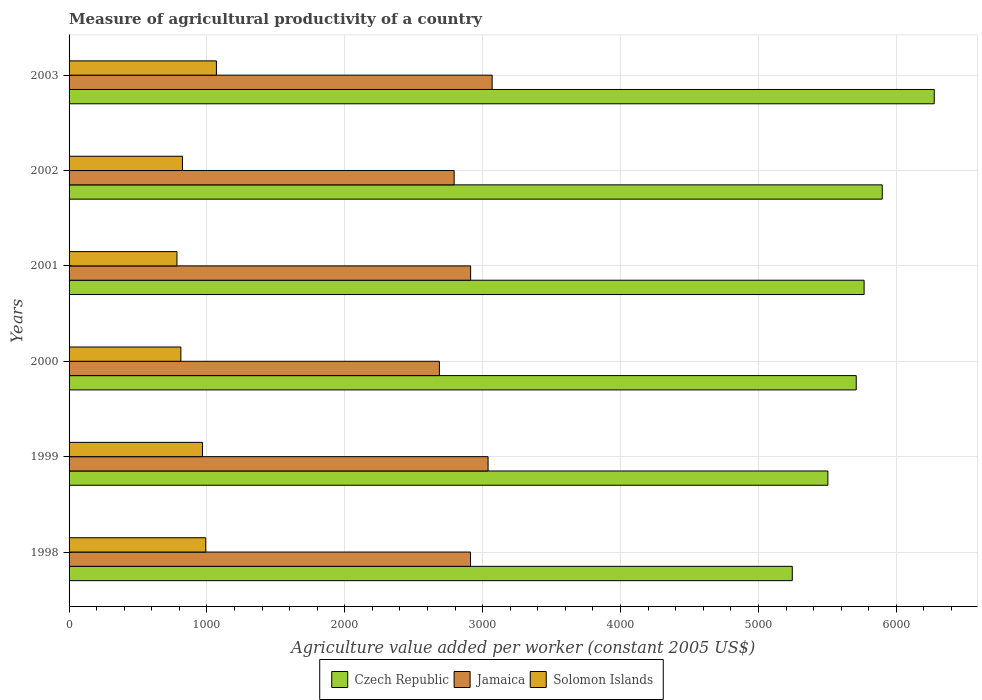How many groups of bars are there?
Give a very brief answer. 6. In how many cases, is the number of bars for a given year not equal to the number of legend labels?
Your answer should be compact. 0. What is the measure of agricultural productivity in Solomon Islands in 2002?
Give a very brief answer. 822.41. Across all years, what is the maximum measure of agricultural productivity in Jamaica?
Offer a terse response. 3068.65. Across all years, what is the minimum measure of agricultural productivity in Solomon Islands?
Provide a short and direct response. 782.48. In which year was the measure of agricultural productivity in Solomon Islands maximum?
Make the answer very short. 2003. In which year was the measure of agricultural productivity in Czech Republic minimum?
Provide a succinct answer. 1998. What is the total measure of agricultural productivity in Jamaica in the graph?
Ensure brevity in your answer.  1.74e+04. What is the difference between the measure of agricultural productivity in Jamaica in 2000 and that in 2003?
Your answer should be compact. -382.64. What is the difference between the measure of agricultural productivity in Czech Republic in 2000 and the measure of agricultural productivity in Solomon Islands in 2002?
Your answer should be very brief. 4886.95. What is the average measure of agricultural productivity in Solomon Islands per year?
Offer a very short reply. 907.22. In the year 1999, what is the difference between the measure of agricultural productivity in Solomon Islands and measure of agricultural productivity in Czech Republic?
Keep it short and to the point. -4535.83. In how many years, is the measure of agricultural productivity in Jamaica greater than 5200 US$?
Your answer should be very brief. 0. What is the ratio of the measure of agricultural productivity in Solomon Islands in 2000 to that in 2003?
Your response must be concise. 0.76. Is the difference between the measure of agricultural productivity in Solomon Islands in 2000 and 2002 greater than the difference between the measure of agricultural productivity in Czech Republic in 2000 and 2002?
Your response must be concise. Yes. What is the difference between the highest and the second highest measure of agricultural productivity in Czech Republic?
Offer a very short reply. 377.08. What is the difference between the highest and the lowest measure of agricultural productivity in Solomon Islands?
Give a very brief answer. 286.23. In how many years, is the measure of agricultural productivity in Jamaica greater than the average measure of agricultural productivity in Jamaica taken over all years?
Give a very brief answer. 4. Is the sum of the measure of agricultural productivity in Czech Republic in 2001 and 2003 greater than the maximum measure of agricultural productivity in Jamaica across all years?
Your answer should be very brief. Yes. What does the 1st bar from the top in 2001 represents?
Ensure brevity in your answer.  Solomon Islands. What does the 2nd bar from the bottom in 2000 represents?
Provide a succinct answer. Jamaica. How many bars are there?
Provide a short and direct response. 18. Are all the bars in the graph horizontal?
Keep it short and to the point. Yes. How many years are there in the graph?
Offer a very short reply. 6. Are the values on the major ticks of X-axis written in scientific E-notation?
Offer a very short reply. No. Does the graph contain any zero values?
Offer a terse response. No. Does the graph contain grids?
Offer a very short reply. Yes. Where does the legend appear in the graph?
Keep it short and to the point. Bottom center. How are the legend labels stacked?
Offer a terse response. Horizontal. What is the title of the graph?
Provide a succinct answer. Measure of agricultural productivity of a country. Does "Ireland" appear as one of the legend labels in the graph?
Make the answer very short. No. What is the label or title of the X-axis?
Ensure brevity in your answer.  Agriculture value added per worker (constant 2005 US$). What is the label or title of the Y-axis?
Give a very brief answer. Years. What is the Agriculture value added per worker (constant 2005 US$) in Czech Republic in 1998?
Your response must be concise. 5245.45. What is the Agriculture value added per worker (constant 2005 US$) in Jamaica in 1998?
Offer a terse response. 2911.57. What is the Agriculture value added per worker (constant 2005 US$) of Solomon Islands in 1998?
Give a very brief answer. 991.28. What is the Agriculture value added per worker (constant 2005 US$) of Czech Republic in 1999?
Provide a short and direct response. 5503.49. What is the Agriculture value added per worker (constant 2005 US$) of Jamaica in 1999?
Offer a very short reply. 3039.08. What is the Agriculture value added per worker (constant 2005 US$) of Solomon Islands in 1999?
Your response must be concise. 967.66. What is the Agriculture value added per worker (constant 2005 US$) in Czech Republic in 2000?
Your response must be concise. 5709.36. What is the Agriculture value added per worker (constant 2005 US$) of Jamaica in 2000?
Your answer should be compact. 2686.01. What is the Agriculture value added per worker (constant 2005 US$) of Solomon Islands in 2000?
Keep it short and to the point. 810.78. What is the Agriculture value added per worker (constant 2005 US$) of Czech Republic in 2001?
Offer a very short reply. 5766.48. What is the Agriculture value added per worker (constant 2005 US$) of Jamaica in 2001?
Your response must be concise. 2912.46. What is the Agriculture value added per worker (constant 2005 US$) in Solomon Islands in 2001?
Provide a short and direct response. 782.48. What is the Agriculture value added per worker (constant 2005 US$) in Czech Republic in 2002?
Provide a short and direct response. 5898.01. What is the Agriculture value added per worker (constant 2005 US$) in Jamaica in 2002?
Keep it short and to the point. 2793.05. What is the Agriculture value added per worker (constant 2005 US$) of Solomon Islands in 2002?
Keep it short and to the point. 822.41. What is the Agriculture value added per worker (constant 2005 US$) of Czech Republic in 2003?
Offer a very short reply. 6275.09. What is the Agriculture value added per worker (constant 2005 US$) of Jamaica in 2003?
Your answer should be very brief. 3068.65. What is the Agriculture value added per worker (constant 2005 US$) in Solomon Islands in 2003?
Your answer should be very brief. 1068.71. Across all years, what is the maximum Agriculture value added per worker (constant 2005 US$) in Czech Republic?
Provide a succinct answer. 6275.09. Across all years, what is the maximum Agriculture value added per worker (constant 2005 US$) in Jamaica?
Offer a terse response. 3068.65. Across all years, what is the maximum Agriculture value added per worker (constant 2005 US$) of Solomon Islands?
Your answer should be very brief. 1068.71. Across all years, what is the minimum Agriculture value added per worker (constant 2005 US$) in Czech Republic?
Keep it short and to the point. 5245.45. Across all years, what is the minimum Agriculture value added per worker (constant 2005 US$) of Jamaica?
Ensure brevity in your answer.  2686.01. Across all years, what is the minimum Agriculture value added per worker (constant 2005 US$) in Solomon Islands?
Keep it short and to the point. 782.48. What is the total Agriculture value added per worker (constant 2005 US$) of Czech Republic in the graph?
Provide a short and direct response. 3.44e+04. What is the total Agriculture value added per worker (constant 2005 US$) of Jamaica in the graph?
Keep it short and to the point. 1.74e+04. What is the total Agriculture value added per worker (constant 2005 US$) in Solomon Islands in the graph?
Your answer should be compact. 5443.32. What is the difference between the Agriculture value added per worker (constant 2005 US$) in Czech Republic in 1998 and that in 1999?
Make the answer very short. -258.04. What is the difference between the Agriculture value added per worker (constant 2005 US$) of Jamaica in 1998 and that in 1999?
Your response must be concise. -127.51. What is the difference between the Agriculture value added per worker (constant 2005 US$) in Solomon Islands in 1998 and that in 1999?
Give a very brief answer. 23.63. What is the difference between the Agriculture value added per worker (constant 2005 US$) of Czech Republic in 1998 and that in 2000?
Your answer should be very brief. -463.91. What is the difference between the Agriculture value added per worker (constant 2005 US$) of Jamaica in 1998 and that in 2000?
Give a very brief answer. 225.56. What is the difference between the Agriculture value added per worker (constant 2005 US$) in Solomon Islands in 1998 and that in 2000?
Provide a succinct answer. 180.5. What is the difference between the Agriculture value added per worker (constant 2005 US$) of Czech Republic in 1998 and that in 2001?
Offer a terse response. -521.03. What is the difference between the Agriculture value added per worker (constant 2005 US$) of Jamaica in 1998 and that in 2001?
Keep it short and to the point. -0.9. What is the difference between the Agriculture value added per worker (constant 2005 US$) in Solomon Islands in 1998 and that in 2001?
Give a very brief answer. 208.8. What is the difference between the Agriculture value added per worker (constant 2005 US$) in Czech Republic in 1998 and that in 2002?
Your answer should be compact. -652.56. What is the difference between the Agriculture value added per worker (constant 2005 US$) of Jamaica in 1998 and that in 2002?
Offer a terse response. 118.52. What is the difference between the Agriculture value added per worker (constant 2005 US$) in Solomon Islands in 1998 and that in 2002?
Keep it short and to the point. 168.87. What is the difference between the Agriculture value added per worker (constant 2005 US$) of Czech Republic in 1998 and that in 2003?
Ensure brevity in your answer.  -1029.64. What is the difference between the Agriculture value added per worker (constant 2005 US$) of Jamaica in 1998 and that in 2003?
Ensure brevity in your answer.  -157.08. What is the difference between the Agriculture value added per worker (constant 2005 US$) in Solomon Islands in 1998 and that in 2003?
Offer a terse response. -77.43. What is the difference between the Agriculture value added per worker (constant 2005 US$) of Czech Republic in 1999 and that in 2000?
Provide a short and direct response. -205.87. What is the difference between the Agriculture value added per worker (constant 2005 US$) in Jamaica in 1999 and that in 2000?
Provide a succinct answer. 353.07. What is the difference between the Agriculture value added per worker (constant 2005 US$) in Solomon Islands in 1999 and that in 2000?
Ensure brevity in your answer.  156.88. What is the difference between the Agriculture value added per worker (constant 2005 US$) in Czech Republic in 1999 and that in 2001?
Your answer should be compact. -262.99. What is the difference between the Agriculture value added per worker (constant 2005 US$) of Jamaica in 1999 and that in 2001?
Provide a short and direct response. 126.61. What is the difference between the Agriculture value added per worker (constant 2005 US$) of Solomon Islands in 1999 and that in 2001?
Keep it short and to the point. 185.18. What is the difference between the Agriculture value added per worker (constant 2005 US$) of Czech Republic in 1999 and that in 2002?
Give a very brief answer. -394.52. What is the difference between the Agriculture value added per worker (constant 2005 US$) of Jamaica in 1999 and that in 2002?
Your answer should be very brief. 246.03. What is the difference between the Agriculture value added per worker (constant 2005 US$) in Solomon Islands in 1999 and that in 2002?
Make the answer very short. 145.25. What is the difference between the Agriculture value added per worker (constant 2005 US$) of Czech Republic in 1999 and that in 2003?
Provide a short and direct response. -771.6. What is the difference between the Agriculture value added per worker (constant 2005 US$) in Jamaica in 1999 and that in 2003?
Provide a succinct answer. -29.57. What is the difference between the Agriculture value added per worker (constant 2005 US$) of Solomon Islands in 1999 and that in 2003?
Provide a short and direct response. -101.06. What is the difference between the Agriculture value added per worker (constant 2005 US$) of Czech Republic in 2000 and that in 2001?
Provide a succinct answer. -57.12. What is the difference between the Agriculture value added per worker (constant 2005 US$) in Jamaica in 2000 and that in 2001?
Make the answer very short. -226.46. What is the difference between the Agriculture value added per worker (constant 2005 US$) in Solomon Islands in 2000 and that in 2001?
Make the answer very short. 28.3. What is the difference between the Agriculture value added per worker (constant 2005 US$) in Czech Republic in 2000 and that in 2002?
Offer a terse response. -188.65. What is the difference between the Agriculture value added per worker (constant 2005 US$) of Jamaica in 2000 and that in 2002?
Your answer should be very brief. -107.04. What is the difference between the Agriculture value added per worker (constant 2005 US$) of Solomon Islands in 2000 and that in 2002?
Keep it short and to the point. -11.63. What is the difference between the Agriculture value added per worker (constant 2005 US$) in Czech Republic in 2000 and that in 2003?
Your answer should be very brief. -565.73. What is the difference between the Agriculture value added per worker (constant 2005 US$) in Jamaica in 2000 and that in 2003?
Offer a very short reply. -382.64. What is the difference between the Agriculture value added per worker (constant 2005 US$) of Solomon Islands in 2000 and that in 2003?
Your answer should be very brief. -257.93. What is the difference between the Agriculture value added per worker (constant 2005 US$) in Czech Republic in 2001 and that in 2002?
Keep it short and to the point. -131.53. What is the difference between the Agriculture value added per worker (constant 2005 US$) of Jamaica in 2001 and that in 2002?
Offer a terse response. 119.42. What is the difference between the Agriculture value added per worker (constant 2005 US$) in Solomon Islands in 2001 and that in 2002?
Keep it short and to the point. -39.93. What is the difference between the Agriculture value added per worker (constant 2005 US$) of Czech Republic in 2001 and that in 2003?
Your answer should be compact. -508.61. What is the difference between the Agriculture value added per worker (constant 2005 US$) of Jamaica in 2001 and that in 2003?
Ensure brevity in your answer.  -156.18. What is the difference between the Agriculture value added per worker (constant 2005 US$) in Solomon Islands in 2001 and that in 2003?
Keep it short and to the point. -286.23. What is the difference between the Agriculture value added per worker (constant 2005 US$) of Czech Republic in 2002 and that in 2003?
Provide a short and direct response. -377.08. What is the difference between the Agriculture value added per worker (constant 2005 US$) in Jamaica in 2002 and that in 2003?
Provide a short and direct response. -275.6. What is the difference between the Agriculture value added per worker (constant 2005 US$) in Solomon Islands in 2002 and that in 2003?
Give a very brief answer. -246.3. What is the difference between the Agriculture value added per worker (constant 2005 US$) in Czech Republic in 1998 and the Agriculture value added per worker (constant 2005 US$) in Jamaica in 1999?
Provide a succinct answer. 2206.37. What is the difference between the Agriculture value added per worker (constant 2005 US$) in Czech Republic in 1998 and the Agriculture value added per worker (constant 2005 US$) in Solomon Islands in 1999?
Provide a short and direct response. 4277.79. What is the difference between the Agriculture value added per worker (constant 2005 US$) in Jamaica in 1998 and the Agriculture value added per worker (constant 2005 US$) in Solomon Islands in 1999?
Give a very brief answer. 1943.91. What is the difference between the Agriculture value added per worker (constant 2005 US$) in Czech Republic in 1998 and the Agriculture value added per worker (constant 2005 US$) in Jamaica in 2000?
Offer a terse response. 2559.44. What is the difference between the Agriculture value added per worker (constant 2005 US$) of Czech Republic in 1998 and the Agriculture value added per worker (constant 2005 US$) of Solomon Islands in 2000?
Make the answer very short. 4434.67. What is the difference between the Agriculture value added per worker (constant 2005 US$) of Jamaica in 1998 and the Agriculture value added per worker (constant 2005 US$) of Solomon Islands in 2000?
Your answer should be compact. 2100.79. What is the difference between the Agriculture value added per worker (constant 2005 US$) of Czech Republic in 1998 and the Agriculture value added per worker (constant 2005 US$) of Jamaica in 2001?
Your answer should be compact. 2332.99. What is the difference between the Agriculture value added per worker (constant 2005 US$) in Czech Republic in 1998 and the Agriculture value added per worker (constant 2005 US$) in Solomon Islands in 2001?
Give a very brief answer. 4462.97. What is the difference between the Agriculture value added per worker (constant 2005 US$) in Jamaica in 1998 and the Agriculture value added per worker (constant 2005 US$) in Solomon Islands in 2001?
Your answer should be very brief. 2129.08. What is the difference between the Agriculture value added per worker (constant 2005 US$) in Czech Republic in 1998 and the Agriculture value added per worker (constant 2005 US$) in Jamaica in 2002?
Offer a terse response. 2452.4. What is the difference between the Agriculture value added per worker (constant 2005 US$) in Czech Republic in 1998 and the Agriculture value added per worker (constant 2005 US$) in Solomon Islands in 2002?
Keep it short and to the point. 4423.04. What is the difference between the Agriculture value added per worker (constant 2005 US$) of Jamaica in 1998 and the Agriculture value added per worker (constant 2005 US$) of Solomon Islands in 2002?
Make the answer very short. 2089.16. What is the difference between the Agriculture value added per worker (constant 2005 US$) of Czech Republic in 1998 and the Agriculture value added per worker (constant 2005 US$) of Jamaica in 2003?
Your answer should be compact. 2176.8. What is the difference between the Agriculture value added per worker (constant 2005 US$) in Czech Republic in 1998 and the Agriculture value added per worker (constant 2005 US$) in Solomon Islands in 2003?
Your answer should be compact. 4176.74. What is the difference between the Agriculture value added per worker (constant 2005 US$) in Jamaica in 1998 and the Agriculture value added per worker (constant 2005 US$) in Solomon Islands in 2003?
Give a very brief answer. 1842.85. What is the difference between the Agriculture value added per worker (constant 2005 US$) in Czech Republic in 1999 and the Agriculture value added per worker (constant 2005 US$) in Jamaica in 2000?
Your answer should be compact. 2817.48. What is the difference between the Agriculture value added per worker (constant 2005 US$) in Czech Republic in 1999 and the Agriculture value added per worker (constant 2005 US$) in Solomon Islands in 2000?
Your answer should be compact. 4692.71. What is the difference between the Agriculture value added per worker (constant 2005 US$) in Jamaica in 1999 and the Agriculture value added per worker (constant 2005 US$) in Solomon Islands in 2000?
Ensure brevity in your answer.  2228.3. What is the difference between the Agriculture value added per worker (constant 2005 US$) of Czech Republic in 1999 and the Agriculture value added per worker (constant 2005 US$) of Jamaica in 2001?
Provide a succinct answer. 2591.03. What is the difference between the Agriculture value added per worker (constant 2005 US$) of Czech Republic in 1999 and the Agriculture value added per worker (constant 2005 US$) of Solomon Islands in 2001?
Offer a very short reply. 4721.01. What is the difference between the Agriculture value added per worker (constant 2005 US$) of Jamaica in 1999 and the Agriculture value added per worker (constant 2005 US$) of Solomon Islands in 2001?
Offer a very short reply. 2256.6. What is the difference between the Agriculture value added per worker (constant 2005 US$) of Czech Republic in 1999 and the Agriculture value added per worker (constant 2005 US$) of Jamaica in 2002?
Provide a short and direct response. 2710.44. What is the difference between the Agriculture value added per worker (constant 2005 US$) of Czech Republic in 1999 and the Agriculture value added per worker (constant 2005 US$) of Solomon Islands in 2002?
Keep it short and to the point. 4681.08. What is the difference between the Agriculture value added per worker (constant 2005 US$) in Jamaica in 1999 and the Agriculture value added per worker (constant 2005 US$) in Solomon Islands in 2002?
Keep it short and to the point. 2216.67. What is the difference between the Agriculture value added per worker (constant 2005 US$) in Czech Republic in 1999 and the Agriculture value added per worker (constant 2005 US$) in Jamaica in 2003?
Your answer should be very brief. 2434.84. What is the difference between the Agriculture value added per worker (constant 2005 US$) in Czech Republic in 1999 and the Agriculture value added per worker (constant 2005 US$) in Solomon Islands in 2003?
Your answer should be compact. 4434.78. What is the difference between the Agriculture value added per worker (constant 2005 US$) of Jamaica in 1999 and the Agriculture value added per worker (constant 2005 US$) of Solomon Islands in 2003?
Your answer should be very brief. 1970.36. What is the difference between the Agriculture value added per worker (constant 2005 US$) in Czech Republic in 2000 and the Agriculture value added per worker (constant 2005 US$) in Jamaica in 2001?
Make the answer very short. 2796.9. What is the difference between the Agriculture value added per worker (constant 2005 US$) of Czech Republic in 2000 and the Agriculture value added per worker (constant 2005 US$) of Solomon Islands in 2001?
Your response must be concise. 4926.88. What is the difference between the Agriculture value added per worker (constant 2005 US$) of Jamaica in 2000 and the Agriculture value added per worker (constant 2005 US$) of Solomon Islands in 2001?
Your answer should be very brief. 1903.53. What is the difference between the Agriculture value added per worker (constant 2005 US$) in Czech Republic in 2000 and the Agriculture value added per worker (constant 2005 US$) in Jamaica in 2002?
Give a very brief answer. 2916.31. What is the difference between the Agriculture value added per worker (constant 2005 US$) of Czech Republic in 2000 and the Agriculture value added per worker (constant 2005 US$) of Solomon Islands in 2002?
Offer a very short reply. 4886.95. What is the difference between the Agriculture value added per worker (constant 2005 US$) of Jamaica in 2000 and the Agriculture value added per worker (constant 2005 US$) of Solomon Islands in 2002?
Your response must be concise. 1863.6. What is the difference between the Agriculture value added per worker (constant 2005 US$) of Czech Republic in 2000 and the Agriculture value added per worker (constant 2005 US$) of Jamaica in 2003?
Offer a terse response. 2640.71. What is the difference between the Agriculture value added per worker (constant 2005 US$) in Czech Republic in 2000 and the Agriculture value added per worker (constant 2005 US$) in Solomon Islands in 2003?
Your answer should be very brief. 4640.65. What is the difference between the Agriculture value added per worker (constant 2005 US$) in Jamaica in 2000 and the Agriculture value added per worker (constant 2005 US$) in Solomon Islands in 2003?
Offer a very short reply. 1617.29. What is the difference between the Agriculture value added per worker (constant 2005 US$) of Czech Republic in 2001 and the Agriculture value added per worker (constant 2005 US$) of Jamaica in 2002?
Offer a terse response. 2973.43. What is the difference between the Agriculture value added per worker (constant 2005 US$) in Czech Republic in 2001 and the Agriculture value added per worker (constant 2005 US$) in Solomon Islands in 2002?
Ensure brevity in your answer.  4944.07. What is the difference between the Agriculture value added per worker (constant 2005 US$) in Jamaica in 2001 and the Agriculture value added per worker (constant 2005 US$) in Solomon Islands in 2002?
Keep it short and to the point. 2090.05. What is the difference between the Agriculture value added per worker (constant 2005 US$) of Czech Republic in 2001 and the Agriculture value added per worker (constant 2005 US$) of Jamaica in 2003?
Give a very brief answer. 2697.83. What is the difference between the Agriculture value added per worker (constant 2005 US$) of Czech Republic in 2001 and the Agriculture value added per worker (constant 2005 US$) of Solomon Islands in 2003?
Keep it short and to the point. 4697.77. What is the difference between the Agriculture value added per worker (constant 2005 US$) of Jamaica in 2001 and the Agriculture value added per worker (constant 2005 US$) of Solomon Islands in 2003?
Provide a succinct answer. 1843.75. What is the difference between the Agriculture value added per worker (constant 2005 US$) of Czech Republic in 2002 and the Agriculture value added per worker (constant 2005 US$) of Jamaica in 2003?
Your answer should be very brief. 2829.36. What is the difference between the Agriculture value added per worker (constant 2005 US$) in Czech Republic in 2002 and the Agriculture value added per worker (constant 2005 US$) in Solomon Islands in 2003?
Provide a short and direct response. 4829.29. What is the difference between the Agriculture value added per worker (constant 2005 US$) in Jamaica in 2002 and the Agriculture value added per worker (constant 2005 US$) in Solomon Islands in 2003?
Keep it short and to the point. 1724.33. What is the average Agriculture value added per worker (constant 2005 US$) in Czech Republic per year?
Your response must be concise. 5732.98. What is the average Agriculture value added per worker (constant 2005 US$) in Jamaica per year?
Give a very brief answer. 2901.8. What is the average Agriculture value added per worker (constant 2005 US$) in Solomon Islands per year?
Offer a terse response. 907.22. In the year 1998, what is the difference between the Agriculture value added per worker (constant 2005 US$) in Czech Republic and Agriculture value added per worker (constant 2005 US$) in Jamaica?
Provide a short and direct response. 2333.88. In the year 1998, what is the difference between the Agriculture value added per worker (constant 2005 US$) of Czech Republic and Agriculture value added per worker (constant 2005 US$) of Solomon Islands?
Offer a terse response. 4254.17. In the year 1998, what is the difference between the Agriculture value added per worker (constant 2005 US$) of Jamaica and Agriculture value added per worker (constant 2005 US$) of Solomon Islands?
Offer a terse response. 1920.28. In the year 1999, what is the difference between the Agriculture value added per worker (constant 2005 US$) in Czech Republic and Agriculture value added per worker (constant 2005 US$) in Jamaica?
Make the answer very short. 2464.41. In the year 1999, what is the difference between the Agriculture value added per worker (constant 2005 US$) of Czech Republic and Agriculture value added per worker (constant 2005 US$) of Solomon Islands?
Provide a short and direct response. 4535.83. In the year 1999, what is the difference between the Agriculture value added per worker (constant 2005 US$) of Jamaica and Agriculture value added per worker (constant 2005 US$) of Solomon Islands?
Provide a succinct answer. 2071.42. In the year 2000, what is the difference between the Agriculture value added per worker (constant 2005 US$) of Czech Republic and Agriculture value added per worker (constant 2005 US$) of Jamaica?
Provide a short and direct response. 3023.35. In the year 2000, what is the difference between the Agriculture value added per worker (constant 2005 US$) in Czech Republic and Agriculture value added per worker (constant 2005 US$) in Solomon Islands?
Give a very brief answer. 4898.58. In the year 2000, what is the difference between the Agriculture value added per worker (constant 2005 US$) in Jamaica and Agriculture value added per worker (constant 2005 US$) in Solomon Islands?
Give a very brief answer. 1875.23. In the year 2001, what is the difference between the Agriculture value added per worker (constant 2005 US$) of Czech Republic and Agriculture value added per worker (constant 2005 US$) of Jamaica?
Give a very brief answer. 2854.02. In the year 2001, what is the difference between the Agriculture value added per worker (constant 2005 US$) of Czech Republic and Agriculture value added per worker (constant 2005 US$) of Solomon Islands?
Make the answer very short. 4984. In the year 2001, what is the difference between the Agriculture value added per worker (constant 2005 US$) of Jamaica and Agriculture value added per worker (constant 2005 US$) of Solomon Islands?
Make the answer very short. 2129.98. In the year 2002, what is the difference between the Agriculture value added per worker (constant 2005 US$) of Czech Republic and Agriculture value added per worker (constant 2005 US$) of Jamaica?
Keep it short and to the point. 3104.96. In the year 2002, what is the difference between the Agriculture value added per worker (constant 2005 US$) of Czech Republic and Agriculture value added per worker (constant 2005 US$) of Solomon Islands?
Offer a very short reply. 5075.6. In the year 2002, what is the difference between the Agriculture value added per worker (constant 2005 US$) of Jamaica and Agriculture value added per worker (constant 2005 US$) of Solomon Islands?
Offer a terse response. 1970.64. In the year 2003, what is the difference between the Agriculture value added per worker (constant 2005 US$) in Czech Republic and Agriculture value added per worker (constant 2005 US$) in Jamaica?
Your response must be concise. 3206.44. In the year 2003, what is the difference between the Agriculture value added per worker (constant 2005 US$) in Czech Republic and Agriculture value added per worker (constant 2005 US$) in Solomon Islands?
Provide a succinct answer. 5206.38. In the year 2003, what is the difference between the Agriculture value added per worker (constant 2005 US$) in Jamaica and Agriculture value added per worker (constant 2005 US$) in Solomon Islands?
Provide a succinct answer. 1999.93. What is the ratio of the Agriculture value added per worker (constant 2005 US$) in Czech Republic in 1998 to that in 1999?
Provide a succinct answer. 0.95. What is the ratio of the Agriculture value added per worker (constant 2005 US$) of Jamaica in 1998 to that in 1999?
Your answer should be compact. 0.96. What is the ratio of the Agriculture value added per worker (constant 2005 US$) in Solomon Islands in 1998 to that in 1999?
Keep it short and to the point. 1.02. What is the ratio of the Agriculture value added per worker (constant 2005 US$) of Czech Republic in 1998 to that in 2000?
Offer a terse response. 0.92. What is the ratio of the Agriculture value added per worker (constant 2005 US$) of Jamaica in 1998 to that in 2000?
Provide a short and direct response. 1.08. What is the ratio of the Agriculture value added per worker (constant 2005 US$) of Solomon Islands in 1998 to that in 2000?
Keep it short and to the point. 1.22. What is the ratio of the Agriculture value added per worker (constant 2005 US$) of Czech Republic in 1998 to that in 2001?
Offer a very short reply. 0.91. What is the ratio of the Agriculture value added per worker (constant 2005 US$) of Solomon Islands in 1998 to that in 2001?
Your response must be concise. 1.27. What is the ratio of the Agriculture value added per worker (constant 2005 US$) in Czech Republic in 1998 to that in 2002?
Your answer should be compact. 0.89. What is the ratio of the Agriculture value added per worker (constant 2005 US$) of Jamaica in 1998 to that in 2002?
Provide a succinct answer. 1.04. What is the ratio of the Agriculture value added per worker (constant 2005 US$) of Solomon Islands in 1998 to that in 2002?
Provide a succinct answer. 1.21. What is the ratio of the Agriculture value added per worker (constant 2005 US$) of Czech Republic in 1998 to that in 2003?
Make the answer very short. 0.84. What is the ratio of the Agriculture value added per worker (constant 2005 US$) of Jamaica in 1998 to that in 2003?
Give a very brief answer. 0.95. What is the ratio of the Agriculture value added per worker (constant 2005 US$) in Solomon Islands in 1998 to that in 2003?
Provide a succinct answer. 0.93. What is the ratio of the Agriculture value added per worker (constant 2005 US$) of Czech Republic in 1999 to that in 2000?
Your answer should be compact. 0.96. What is the ratio of the Agriculture value added per worker (constant 2005 US$) in Jamaica in 1999 to that in 2000?
Offer a very short reply. 1.13. What is the ratio of the Agriculture value added per worker (constant 2005 US$) in Solomon Islands in 1999 to that in 2000?
Make the answer very short. 1.19. What is the ratio of the Agriculture value added per worker (constant 2005 US$) in Czech Republic in 1999 to that in 2001?
Your response must be concise. 0.95. What is the ratio of the Agriculture value added per worker (constant 2005 US$) in Jamaica in 1999 to that in 2001?
Give a very brief answer. 1.04. What is the ratio of the Agriculture value added per worker (constant 2005 US$) in Solomon Islands in 1999 to that in 2001?
Your answer should be compact. 1.24. What is the ratio of the Agriculture value added per worker (constant 2005 US$) of Czech Republic in 1999 to that in 2002?
Ensure brevity in your answer.  0.93. What is the ratio of the Agriculture value added per worker (constant 2005 US$) of Jamaica in 1999 to that in 2002?
Provide a succinct answer. 1.09. What is the ratio of the Agriculture value added per worker (constant 2005 US$) in Solomon Islands in 1999 to that in 2002?
Your answer should be compact. 1.18. What is the ratio of the Agriculture value added per worker (constant 2005 US$) of Czech Republic in 1999 to that in 2003?
Your answer should be very brief. 0.88. What is the ratio of the Agriculture value added per worker (constant 2005 US$) of Solomon Islands in 1999 to that in 2003?
Make the answer very short. 0.91. What is the ratio of the Agriculture value added per worker (constant 2005 US$) in Czech Republic in 2000 to that in 2001?
Offer a terse response. 0.99. What is the ratio of the Agriculture value added per worker (constant 2005 US$) of Jamaica in 2000 to that in 2001?
Keep it short and to the point. 0.92. What is the ratio of the Agriculture value added per worker (constant 2005 US$) of Solomon Islands in 2000 to that in 2001?
Provide a short and direct response. 1.04. What is the ratio of the Agriculture value added per worker (constant 2005 US$) of Jamaica in 2000 to that in 2002?
Offer a terse response. 0.96. What is the ratio of the Agriculture value added per worker (constant 2005 US$) in Solomon Islands in 2000 to that in 2002?
Your answer should be very brief. 0.99. What is the ratio of the Agriculture value added per worker (constant 2005 US$) in Czech Republic in 2000 to that in 2003?
Keep it short and to the point. 0.91. What is the ratio of the Agriculture value added per worker (constant 2005 US$) of Jamaica in 2000 to that in 2003?
Give a very brief answer. 0.88. What is the ratio of the Agriculture value added per worker (constant 2005 US$) of Solomon Islands in 2000 to that in 2003?
Provide a succinct answer. 0.76. What is the ratio of the Agriculture value added per worker (constant 2005 US$) in Czech Republic in 2001 to that in 2002?
Keep it short and to the point. 0.98. What is the ratio of the Agriculture value added per worker (constant 2005 US$) in Jamaica in 2001 to that in 2002?
Your answer should be very brief. 1.04. What is the ratio of the Agriculture value added per worker (constant 2005 US$) in Solomon Islands in 2001 to that in 2002?
Your answer should be very brief. 0.95. What is the ratio of the Agriculture value added per worker (constant 2005 US$) of Czech Republic in 2001 to that in 2003?
Your answer should be very brief. 0.92. What is the ratio of the Agriculture value added per worker (constant 2005 US$) in Jamaica in 2001 to that in 2003?
Keep it short and to the point. 0.95. What is the ratio of the Agriculture value added per worker (constant 2005 US$) in Solomon Islands in 2001 to that in 2003?
Offer a very short reply. 0.73. What is the ratio of the Agriculture value added per worker (constant 2005 US$) in Czech Republic in 2002 to that in 2003?
Keep it short and to the point. 0.94. What is the ratio of the Agriculture value added per worker (constant 2005 US$) in Jamaica in 2002 to that in 2003?
Offer a very short reply. 0.91. What is the ratio of the Agriculture value added per worker (constant 2005 US$) in Solomon Islands in 2002 to that in 2003?
Offer a very short reply. 0.77. What is the difference between the highest and the second highest Agriculture value added per worker (constant 2005 US$) of Czech Republic?
Keep it short and to the point. 377.08. What is the difference between the highest and the second highest Agriculture value added per worker (constant 2005 US$) in Jamaica?
Your answer should be compact. 29.57. What is the difference between the highest and the second highest Agriculture value added per worker (constant 2005 US$) in Solomon Islands?
Give a very brief answer. 77.43. What is the difference between the highest and the lowest Agriculture value added per worker (constant 2005 US$) in Czech Republic?
Provide a succinct answer. 1029.64. What is the difference between the highest and the lowest Agriculture value added per worker (constant 2005 US$) of Jamaica?
Offer a terse response. 382.64. What is the difference between the highest and the lowest Agriculture value added per worker (constant 2005 US$) of Solomon Islands?
Keep it short and to the point. 286.23. 